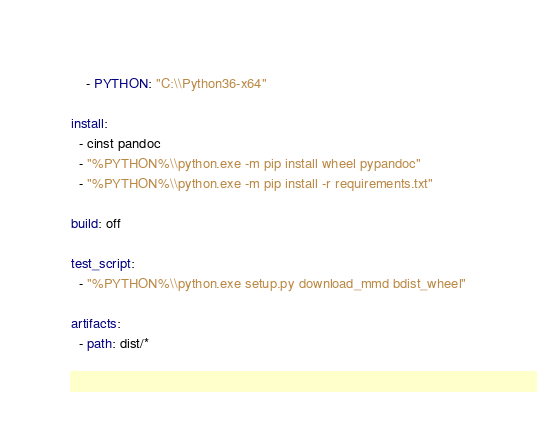<code> <loc_0><loc_0><loc_500><loc_500><_YAML_>    - PYTHON: "C:\\Python36-x64"

install:
  - cinst pandoc
  - "%PYTHON%\\python.exe -m pip install wheel pypandoc"
  - "%PYTHON%\\python.exe -m pip install -r requirements.txt"

build: off

test_script:
  - "%PYTHON%\\python.exe setup.py download_mmd bdist_wheel"

artifacts:
  - path: dist/*</code> 